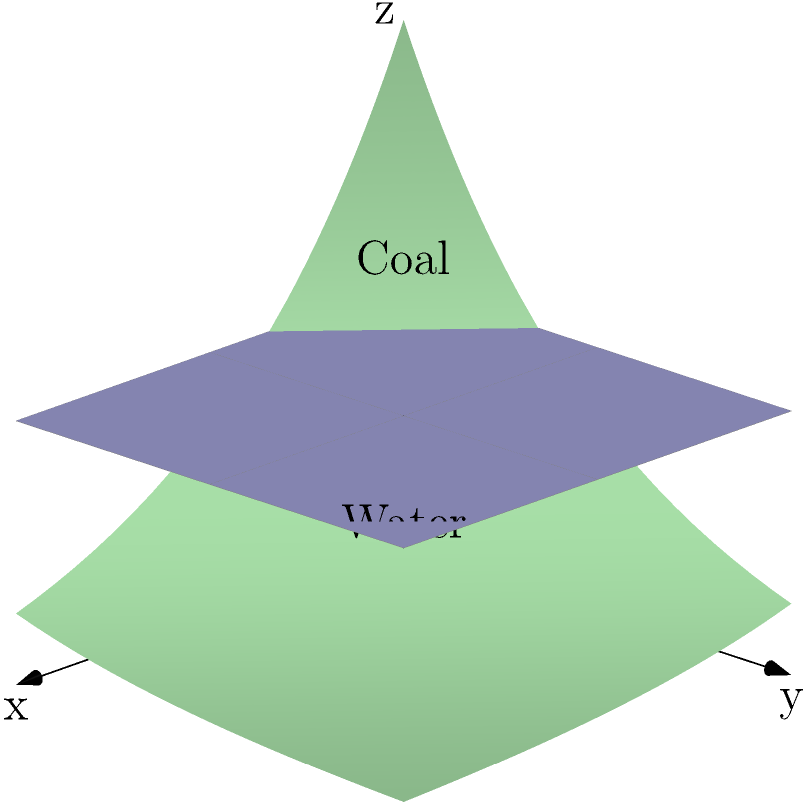A coal mine's volume is modeled by the function $V(t) = 1000e^{-0.05t}$ cubic meters, where $t$ is measured in years. If the mine is flooded with water at a constant rate of 10 cubic meters per year, after how many years will the mine be half filled with water? Let's approach this step-by-step:

1) The initial volume of the mine is $V(0) = 1000e^{-0.05(0)} = 1000$ cubic meters.

2) We need to find $t$ when the volume of water equals half the mine's volume:
   $500 = 1000e^{-0.05t} - 10t$

3) This equation cannot be solved algebraically. We need to use numerical methods or graphing to find the solution.

4) Using a graphing calculator or computer software, we can plot two functions:
   $y_1 = 500$
   $y_2 = 1000e^{-0.05t} - 10t$

5) The point where these functions intersect gives us the solution.

6) By using such methods, we find that the intersection occurs at approximately $t = 13.86$ years.

This solution highlights the exponential depletion of the mine's volume due to coal extraction (represented by the exponential term) and the linear increase in water volume. It demonstrates the complex interplay between resource extraction and environmental factors in mining operations.
Answer: Approximately 13.86 years 